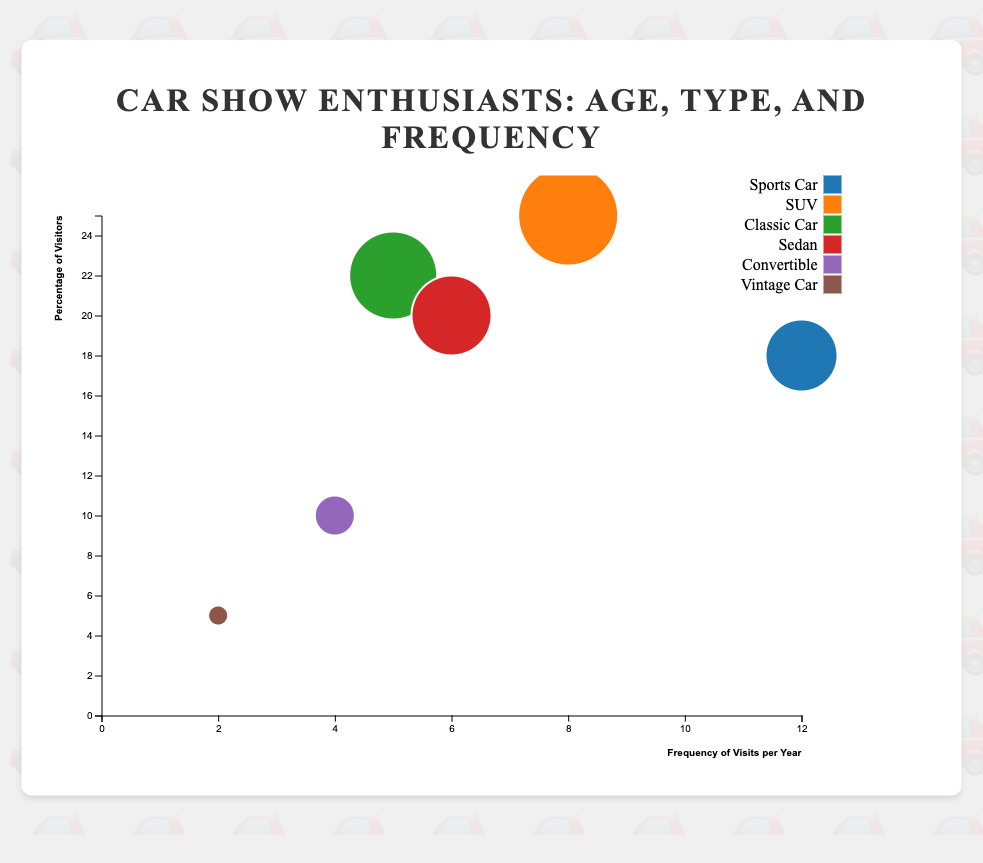What is the title of the chart? The title of the chart is displayed at the top center of the figure, indicating its content.
Answer: Car Show Enthusiasts: Age, Type, and Frequency Which age group visits car shows the most frequently per year? Look at the "Frequency of Visits per Year" axis and check which age group has the highest value.
Answer: 18-25 What car type is most popular among the 26-35 age group? Check the bubble representing the 26-35 age group and see its corresponding car type.
Answer: SUV How many age groups are represented in the chart? Count the number of unique age group labels on the bubbles in the chart.
Answer: 6 What is the percentage of visitors for the 46-55 age group? Refer to the size of the bubble representing the 46-55 age group, which indicates the percentage.
Answer: 20% Which age group has the lowest frequency of visits per year, and what car type do they prefer? Identify the bubble with the smallest frequency on the "Frequency of Visits per Year" axis and check its corresponding age group and car type.
Answer: 66 and above, Vintage Car Compare the frequency of visits between the 26-35 age group and the 56-65 age group. Which group visits more often? Check the "Frequency of Visits per Year" values for both age groups and compare them.
Answer: 26-35 What is the total percentage of visitors for age groups 36-45 and 46-55? Add the percentages of visitors for the 36-45 and 46-55 age groups: 22% + 20%.
Answer: 42% Which car type is indicated by the bubble with the second highest frequency of visits? Find the bubble with the second highest value on the "Frequency of Visits per Year" axis and identify its car type.
Answer: SUV Is the percentage of visitors for the 56-65 age group greater or less than that for the 18-25 age group? Compare the sizes of the bubbles representing the 56-65 and 18-25 age groups as indicated by their percentages.
Answer: Less 